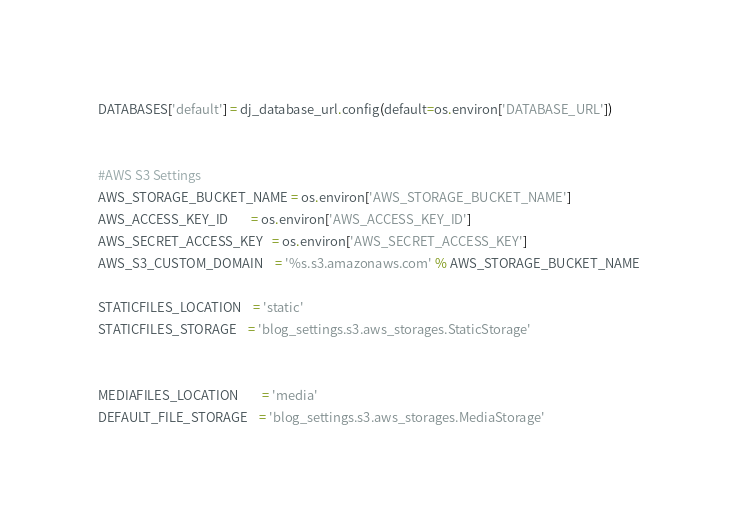<code> <loc_0><loc_0><loc_500><loc_500><_Python_>DATABASES['default'] = dj_database_url.config(default=os.environ['DATABASE_URL'])


#AWS S3 Settings
AWS_STORAGE_BUCKET_NAME = os.environ['AWS_STORAGE_BUCKET_NAME']
AWS_ACCESS_KEY_ID 		= os.environ['AWS_ACCESS_KEY_ID']
AWS_SECRET_ACCESS_KEY   = os.environ['AWS_SECRET_ACCESS_KEY']
AWS_S3_CUSTOM_DOMAIN 	= '%s.s3.amazonaws.com' % AWS_STORAGE_BUCKET_NAME

STATICFILES_LOCATION	= 'static'
STATICFILES_STORAGE 	= 'blog_settings.s3.aws_storages.StaticStorage'

 
MEDIAFILES_LOCATION		= 'media'
DEFAULT_FILE_STORAGE	= 'blog_settings.s3.aws_storages.MediaStorage'</code> 